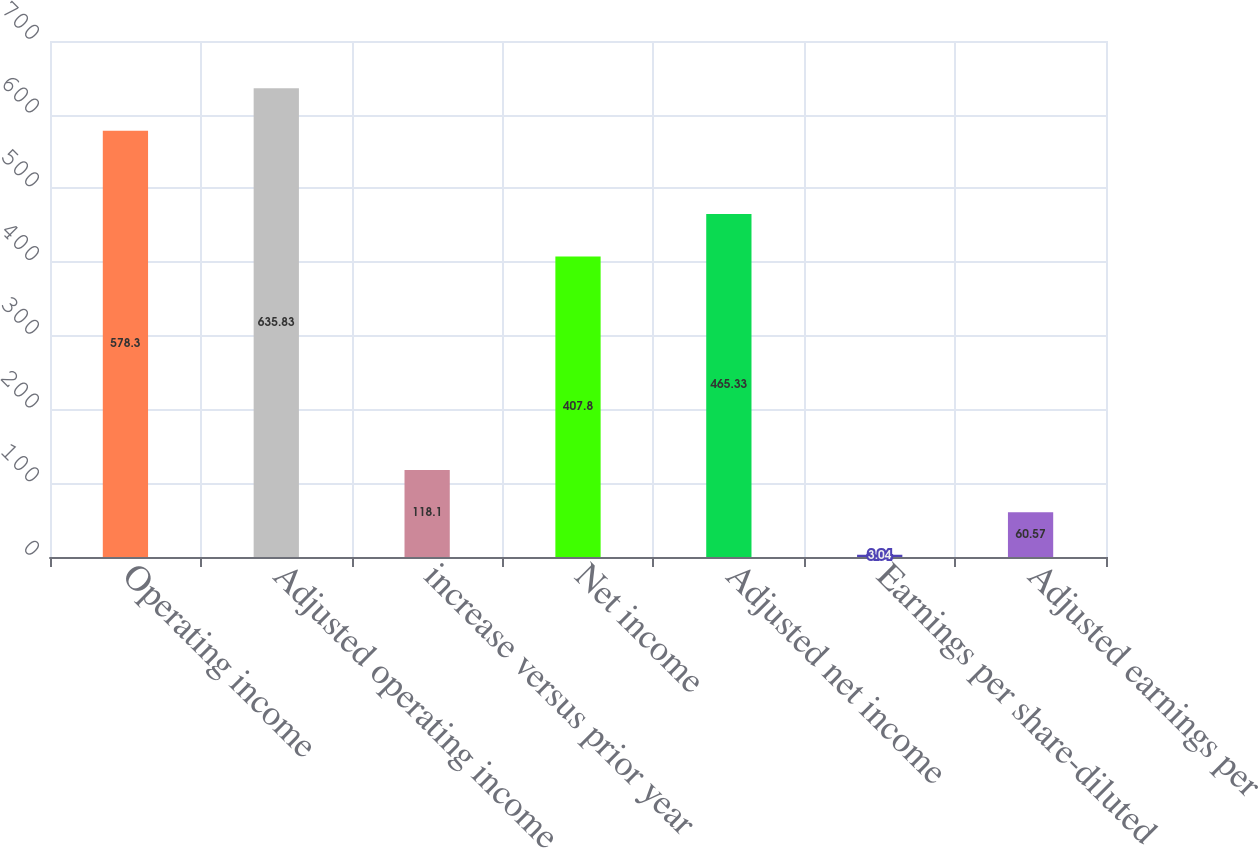<chart> <loc_0><loc_0><loc_500><loc_500><bar_chart><fcel>Operating income<fcel>Adjusted operating income<fcel>increase versus prior year<fcel>Net income<fcel>Adjusted net income<fcel>Earnings per share-diluted<fcel>Adjusted earnings per<nl><fcel>578.3<fcel>635.83<fcel>118.1<fcel>407.8<fcel>465.33<fcel>3.04<fcel>60.57<nl></chart> 